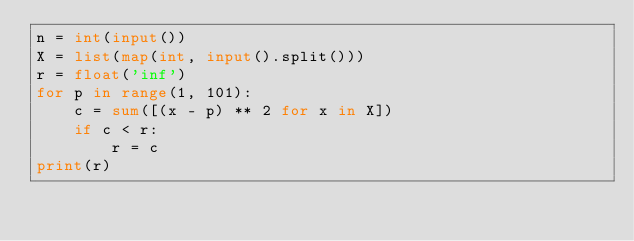Convert code to text. <code><loc_0><loc_0><loc_500><loc_500><_Python_>n = int(input())
X = list(map(int, input().split()))
r = float('inf')
for p in range(1, 101):
    c = sum([(x - p) ** 2 for x in X])
    if c < r:
        r = c
print(r)
</code> 